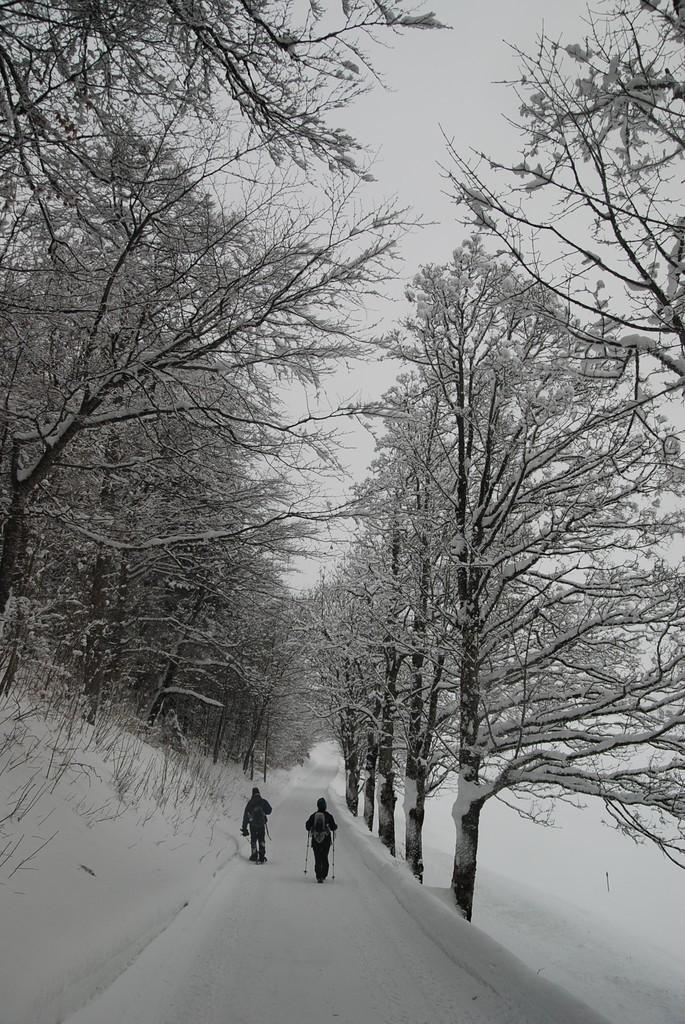How many people are in the image? There are two persons in the image. What are the persons doing in the image? The persons are walking in the middle of a path. What can be seen on either side of the path? Trees are present on either side of the path. What is the condition of the ground in the image? The path is on a snow-covered land. What is visible above the path? The sky is visible above the path. What type of table can be seen in the image? There is no table present in the image; it features two persons walking on a snow-covered path with trees on either side. How many boats are visible in the image? There are no boats present in the image; it features two persons walking on a snow-covered path with trees on either side. 